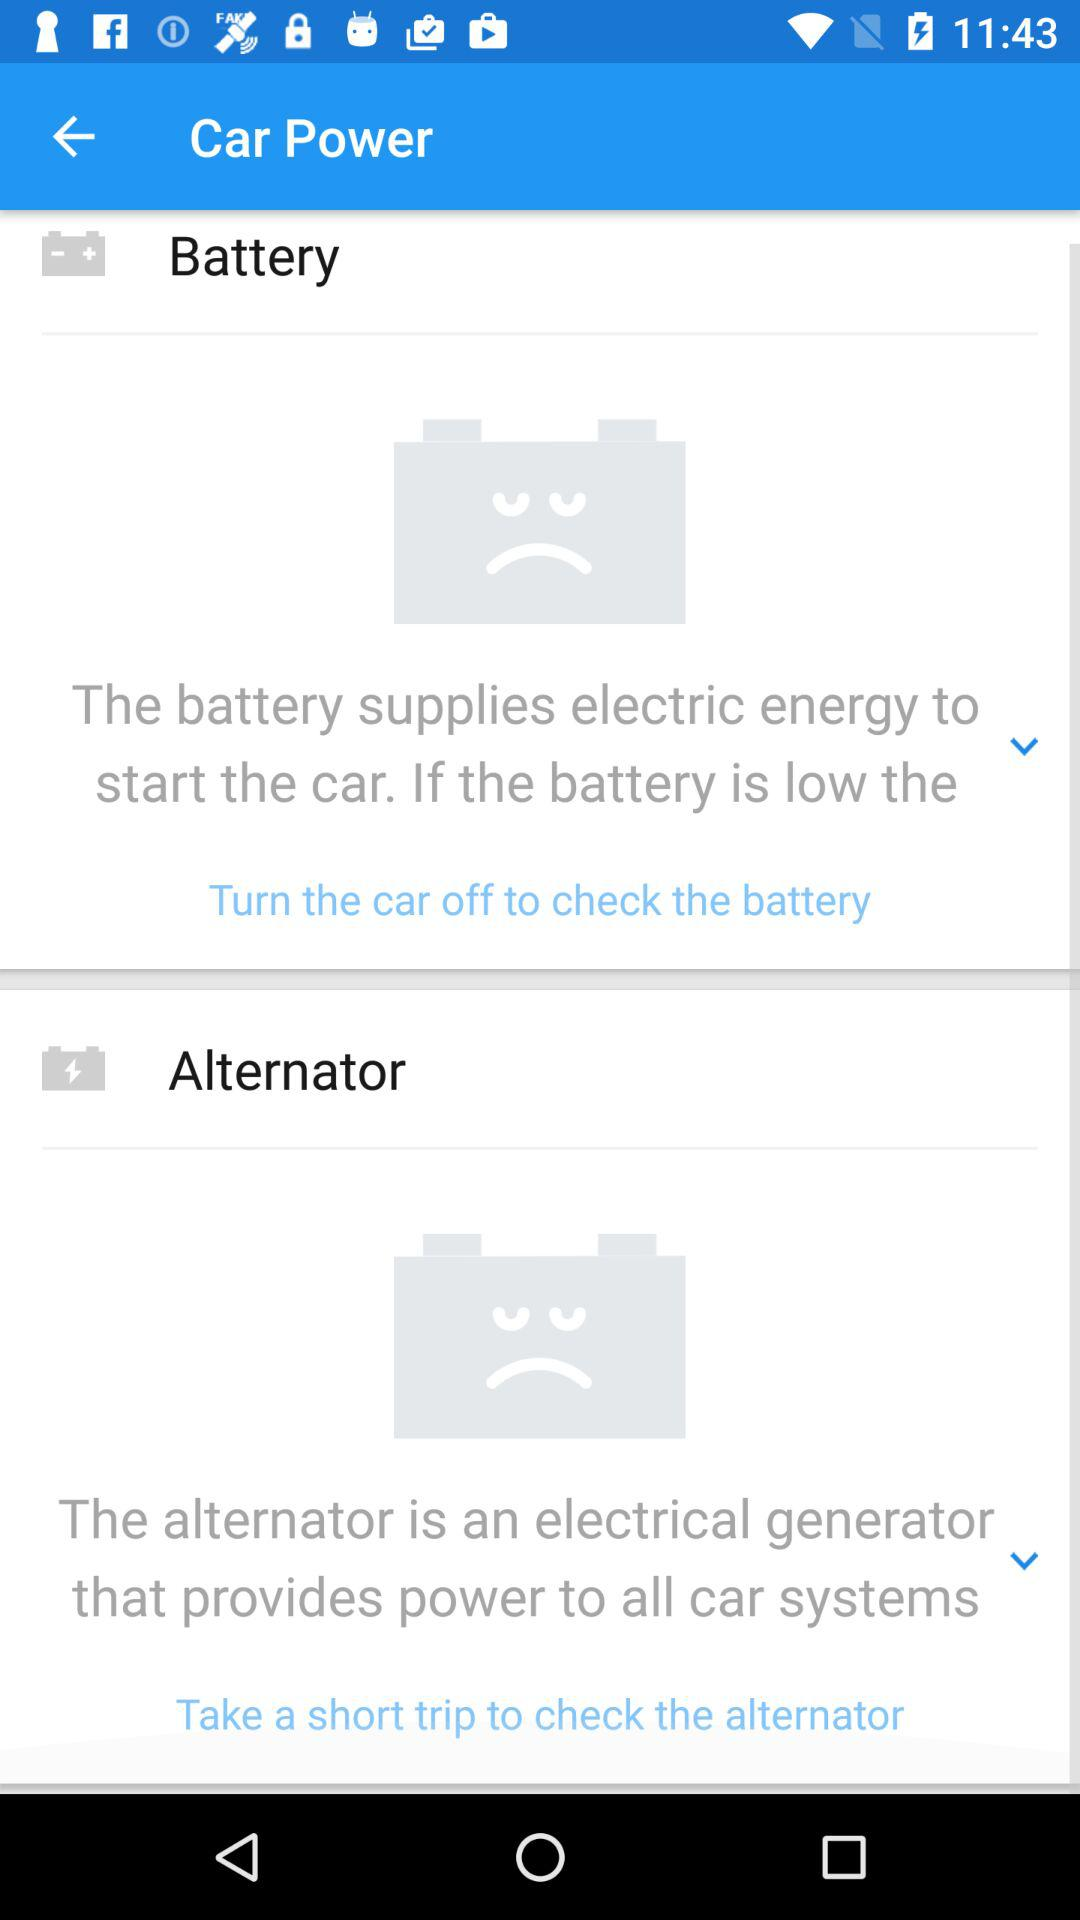What is the alternator? The alternator is an electrical generator that provides power to all car systems. 